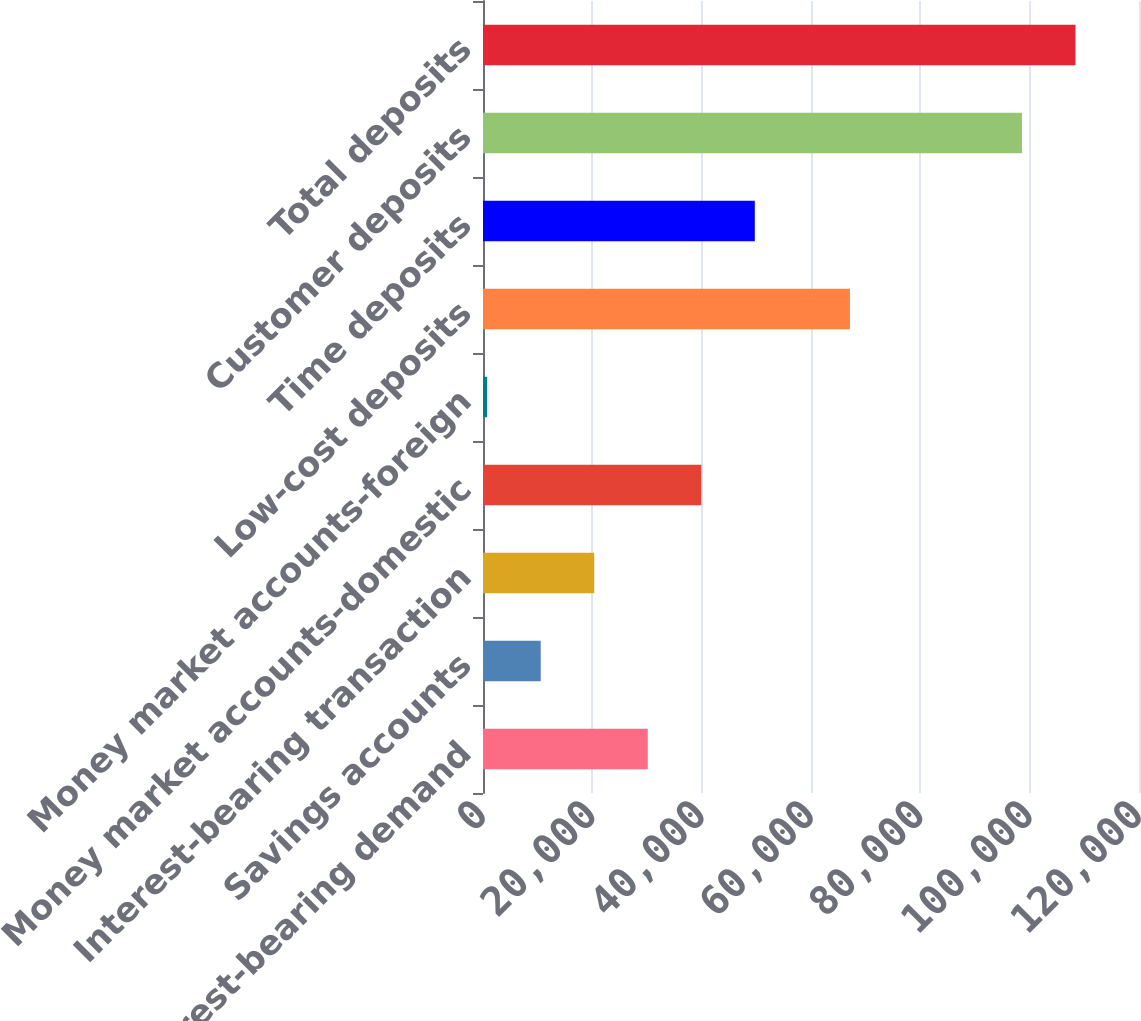Convert chart to OTSL. <chart><loc_0><loc_0><loc_500><loc_500><bar_chart><fcel>Non-interest-bearing demand<fcel>Savings accounts<fcel>Interest-bearing transaction<fcel>Money market accounts-domestic<fcel>Money market accounts-foreign<fcel>Low-cost deposits<fcel>Time deposits<fcel>Customer deposits<fcel>Total deposits<nl><fcel>30140.2<fcel>10557.4<fcel>20348.8<fcel>39931.6<fcel>766<fcel>67125<fcel>49723<fcel>98593<fcel>108384<nl></chart> 